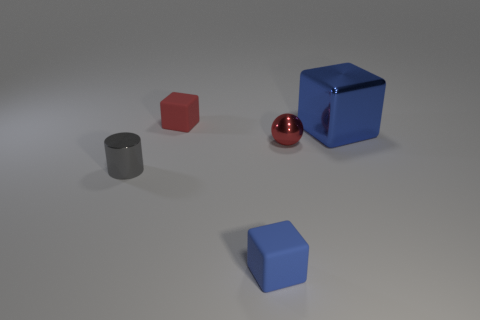What number of matte cubes are in front of the cube right of the blue matte object in front of the small red matte block? There is one matte cube positioned in front of the cube that is to the right of the larger blue matte cube, which itself is in front of the small red matte block. To clarify, when facing the small red block, the larger blue cube is directly in front of it, and to the right of this blue cube is another cube, which has one cube in front of it, visible from this perspective. 